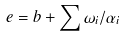Convert formula to latex. <formula><loc_0><loc_0><loc_500><loc_500>e = b + \sum \omega _ { i } / \alpha _ { i }</formula> 